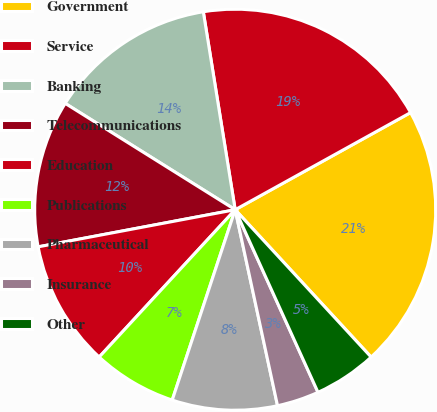Convert chart to OTSL. <chart><loc_0><loc_0><loc_500><loc_500><pie_chart><fcel>Government<fcel>Service<fcel>Banking<fcel>Telecommunications<fcel>Education<fcel>Publications<fcel>Pharmaceutical<fcel>Insurance<fcel>Other<nl><fcel>21.19%<fcel>19.49%<fcel>13.56%<fcel>11.86%<fcel>10.17%<fcel>6.78%<fcel>8.47%<fcel>3.39%<fcel>5.08%<nl></chart> 